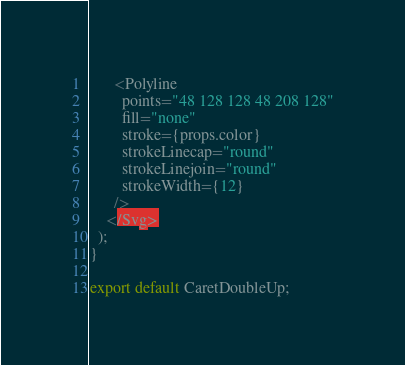Convert code to text. <code><loc_0><loc_0><loc_500><loc_500><_TypeScript_>      <Polyline
        points="48 128 128 48 208 128"
        fill="none"
        stroke={props.color}
        strokeLinecap="round"
        strokeLinejoin="round"
        strokeWidth={12}
      />
    </Svg>
  );
}

export default CaretDoubleUp;
</code> 